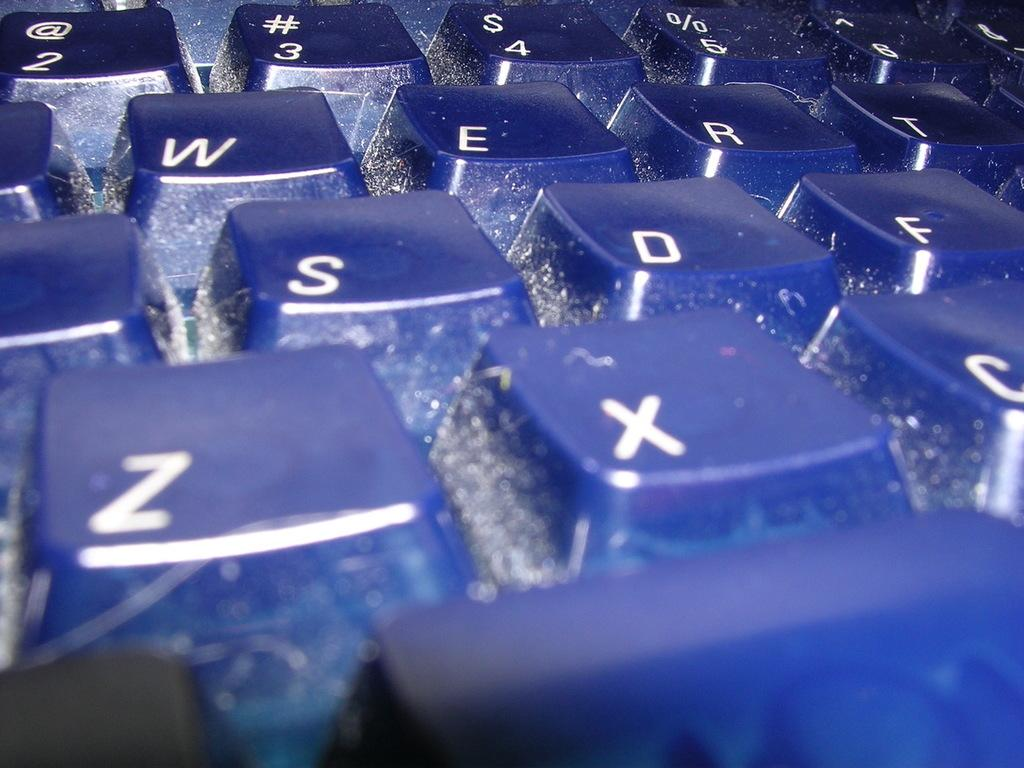<image>
Offer a succinct explanation of the picture presented. A black keyboard has keys for Z and X on it. 